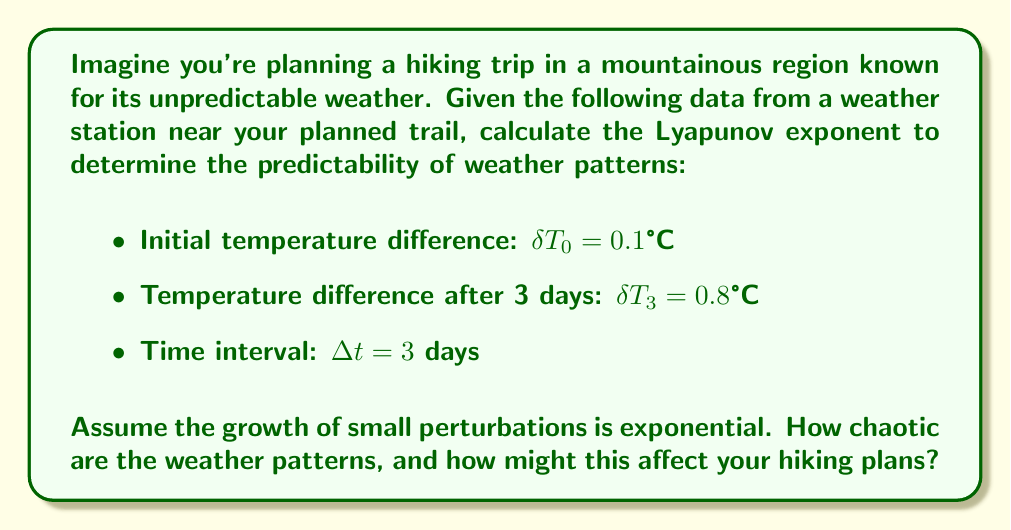Can you answer this question? To calculate the Lyapunov exponent (λ) for this weather system, we'll follow these steps:

1. Recall the formula for the Lyapunov exponent:

   $$\lambda = \frac{1}{\Delta t} \ln\left(\frac{\delta T_3}{\delta T_0}\right)$$

2. Substitute the given values:
   $\delta T_0 = 0.1°C$
   $\delta T_3 = 0.8°C$
   $\Delta t = 3$ days

3. Calculate:

   $$\lambda = \frac{1}{3} \ln\left(\frac{0.8}{0.1}\right)$$

4. Simplify inside the logarithm:

   $$\lambda = \frac{1}{3} \ln(8)$$

5. Evaluate the logarithm:

   $$\lambda = \frac{1}{3} \cdot 2.0794 \approx 0.6931$$

6. Interpret the result:
   The positive Lyapunov exponent (λ ≈ 0.6931) indicates chaotic behavior in the weather system. This means that small changes in initial conditions can lead to significant differences in weather patterns over time.

   For a hiker with a fear of insects, this unpredictability could be concerning. Chaotic weather patterns might lead to sudden temperature changes or unexpected precipitation, which could affect insect activity and potentially impact hiking conditions. It would be advisable to prepare for a wide range of weather conditions and possibly consider alternative trails with more stable weather patterns.
Answer: $\lambda \approx 0.6931$ day$^{-1}$ 